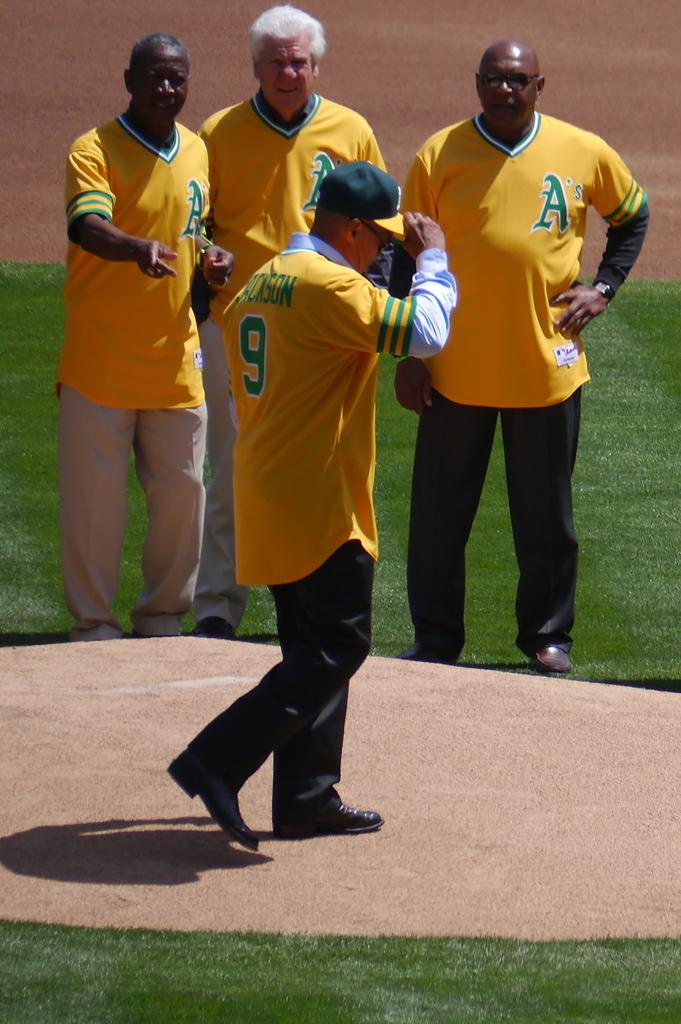<image>
Offer a succinct explanation of the picture presented. The men are wearing Oakland A's yellow and green jersey. 